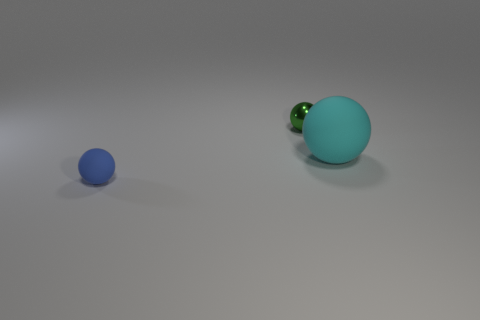Add 2 tiny matte objects. How many objects exist? 5 Subtract 0 red cubes. How many objects are left? 3 Subtract all brown cubes. Subtract all shiny objects. How many objects are left? 2 Add 3 balls. How many balls are left? 6 Add 2 big yellow matte spheres. How many big yellow matte spheres exist? 2 